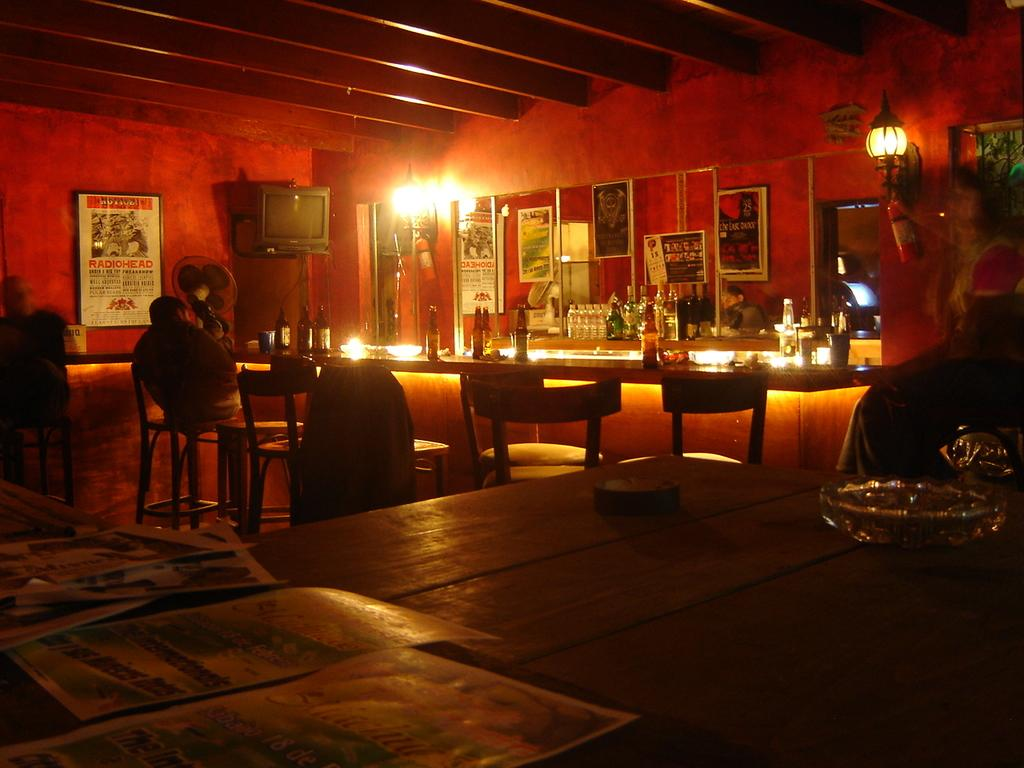What piece of furniture is present in the image? There is a table in the image. What is on the table in the image? There are wine bottles on the table. What type of seating is visible in the image? There are chairs in the image. What can be seen in the background of the image? There is a television in the background of the image, and the wall is red. How much knowledge can be gained from the hill in the image? There is no hill present in the image, so it is not possible to gain knowledge from it. 